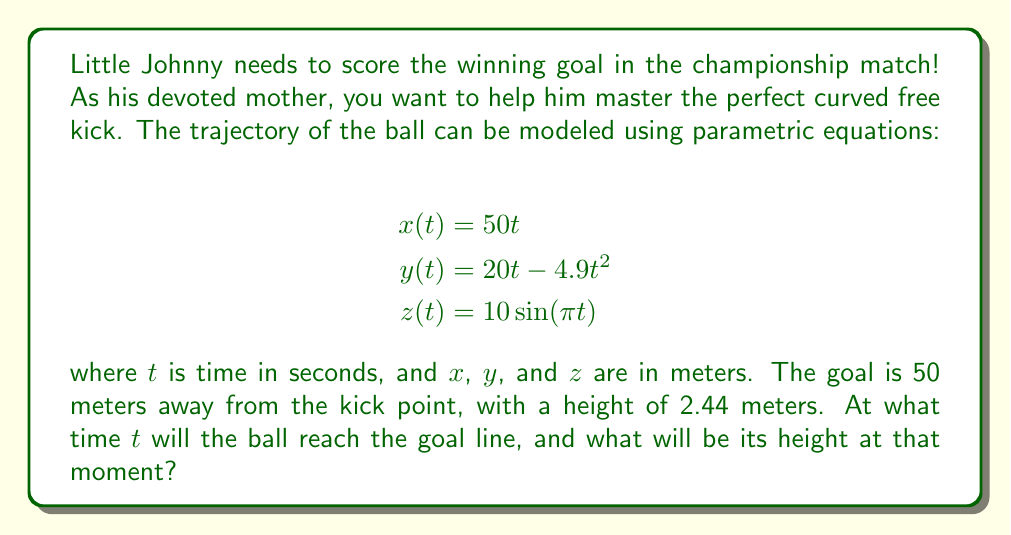Could you help me with this problem? Let's approach this step-by-step:

1) First, we need to find when the ball reaches the goal line. The goal is 50 meters away, so we need to solve:

   $$50 = 50t$$

2) Solving this equation:
   
   $$t = 1 \text{ second}$$

3) Now that we know the time, we can calculate the height of the ball at this moment. The height is given by the $y$ equation:

   $$y(1) = 20(1) - 4.9(1)^2 = 20 - 4.9 = 15.1 \text{ meters}$$

4) We should also check the $z$ coordinate at $t=1$:

   $$z(1) = 10\sin(\pi(1)) = 0 \text{ meters}$$

5) This means the ball will be directly above the goal line, with no sideways deviation.

6) The ball will be well above the goal's height of 2.44 meters when it crosses the goal line.
Answer: $t = 1$ second, height = $15.1$ meters 